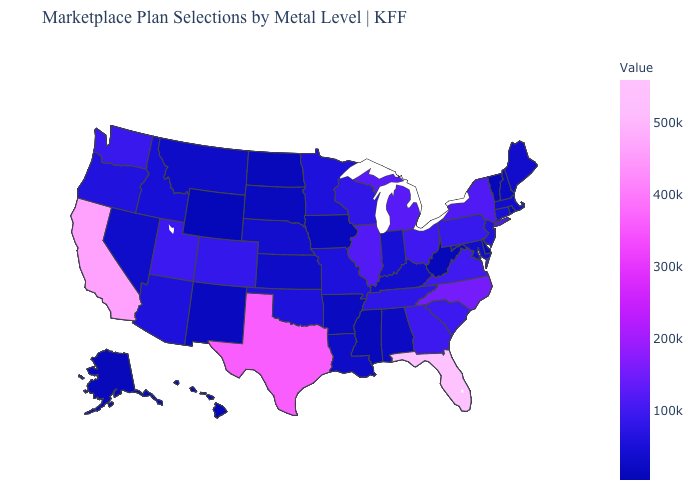Which states have the highest value in the USA?
Be succinct. Florida. Does Texas have the highest value in the USA?
Concise answer only. No. Which states have the lowest value in the MidWest?
Answer briefly. North Dakota. Does Alaska have a lower value than Pennsylvania?
Short answer required. Yes. Does the map have missing data?
Write a very short answer. No. Which states have the highest value in the USA?
Give a very brief answer. Florida. 